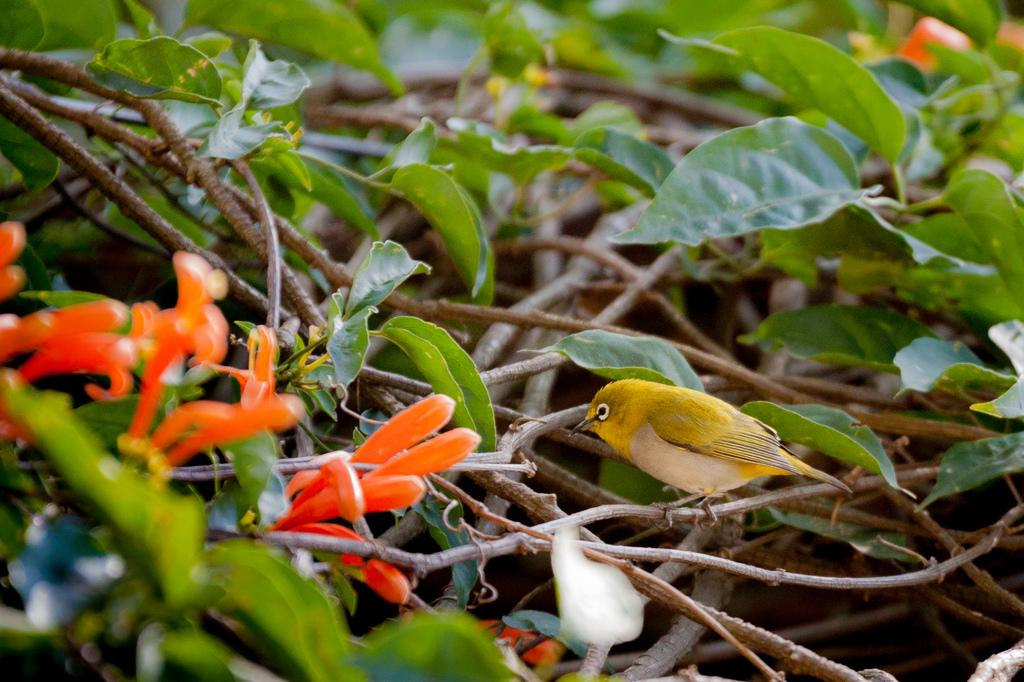What type of living organisms can be seen in the image? Plants and flowers are visible in the image. Are there any animals present in the image? Yes, there is a bird on the plants. What type of bed can be seen in the image? There is no bed present in the image. What kind of laborer is working in the image? There is no laborer present in the image. 